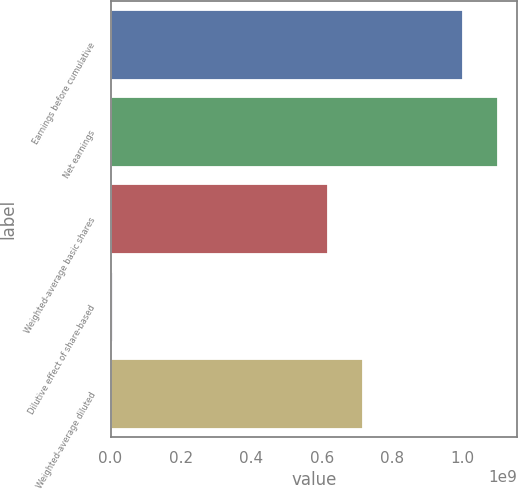Convert chart. <chart><loc_0><loc_0><loc_500><loc_500><bar_chart><fcel>Earnings before cumulative<fcel>Net earnings<fcel>Weighted-average basic shares<fcel>Dilutive effect of share-based<fcel>Weighted-average diluted<nl><fcel>1.00108e+09<fcel>1.10038e+09<fcel>6.18333e+08<fcel>8.03405e+06<fcel>7.17637e+08<nl></chart> 